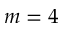<formula> <loc_0><loc_0><loc_500><loc_500>m = 4</formula> 